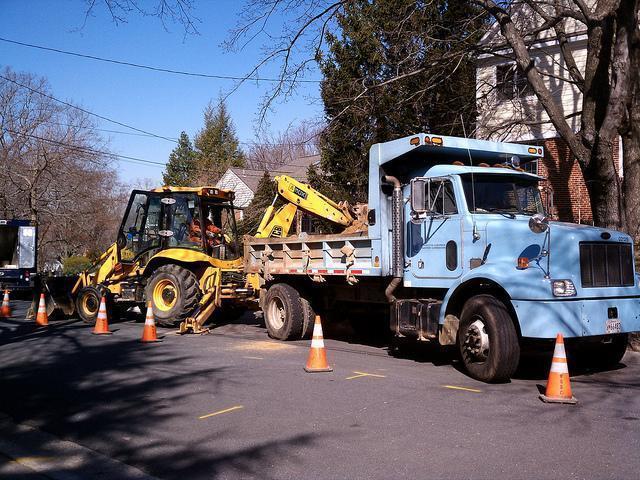What is near the blue truck?
From the following four choices, select the correct answer to address the question.
Options: Traffic cone, carrot, horse, stop sign. Traffic cone. 